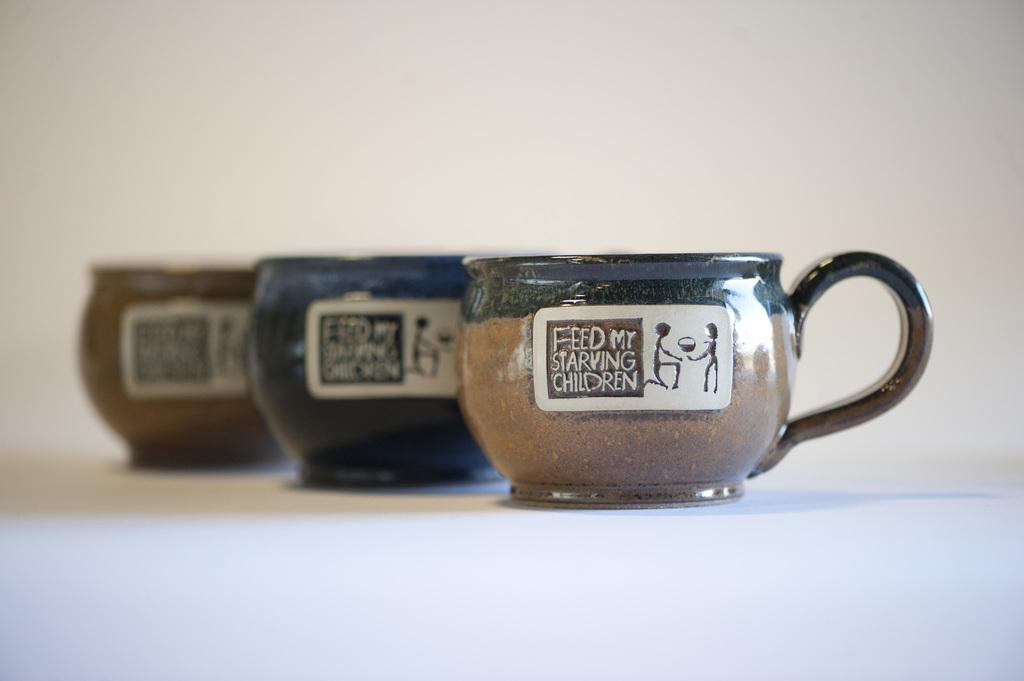Could you give a brief overview of what you see in this image? In this image we can see three cups on white surface. 